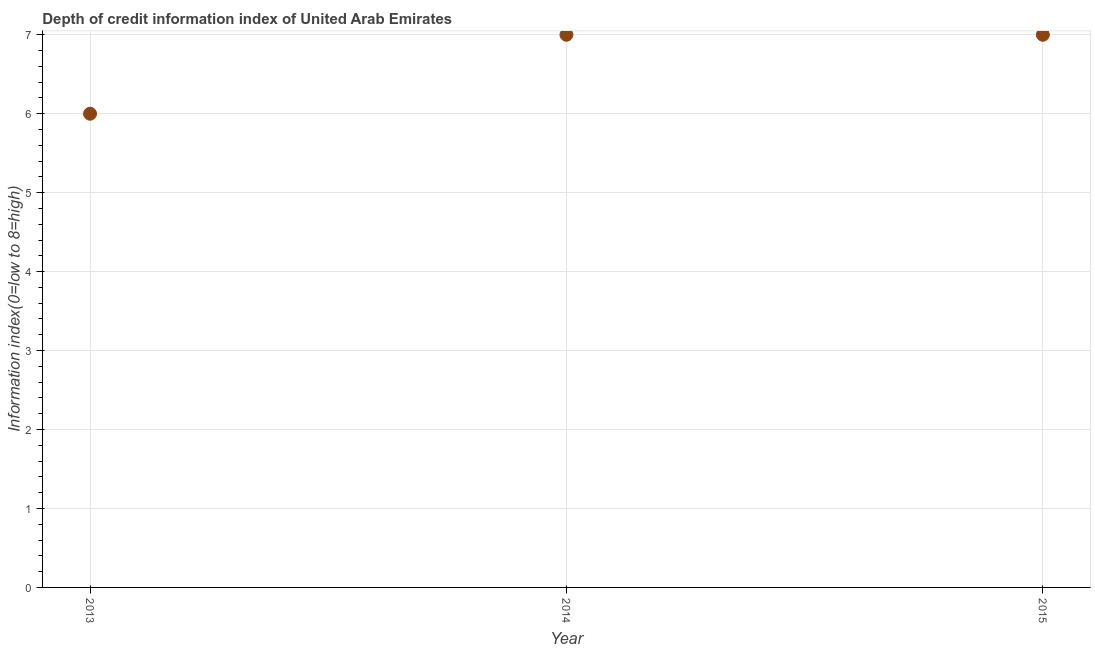What is the depth of credit information index in 2014?
Your response must be concise. 7. Across all years, what is the maximum depth of credit information index?
Give a very brief answer. 7. In which year was the depth of credit information index maximum?
Keep it short and to the point. 2014. What is the sum of the depth of credit information index?
Offer a terse response. 20. What is the difference between the depth of credit information index in 2013 and 2015?
Provide a short and direct response. -1. What is the average depth of credit information index per year?
Keep it short and to the point. 6.67. In how many years, is the depth of credit information index greater than 1.6 ?
Ensure brevity in your answer.  3. What is the ratio of the depth of credit information index in 2013 to that in 2015?
Ensure brevity in your answer.  0.86. What is the difference between the highest and the lowest depth of credit information index?
Offer a very short reply. 1. In how many years, is the depth of credit information index greater than the average depth of credit information index taken over all years?
Your answer should be compact. 2. Does the depth of credit information index monotonically increase over the years?
Ensure brevity in your answer.  No. How many dotlines are there?
Give a very brief answer. 1. What is the difference between two consecutive major ticks on the Y-axis?
Provide a short and direct response. 1. What is the title of the graph?
Your response must be concise. Depth of credit information index of United Arab Emirates. What is the label or title of the Y-axis?
Your answer should be compact. Information index(0=low to 8=high). What is the Information index(0=low to 8=high) in 2015?
Your answer should be very brief. 7. What is the difference between the Information index(0=low to 8=high) in 2013 and 2015?
Your response must be concise. -1. What is the difference between the Information index(0=low to 8=high) in 2014 and 2015?
Give a very brief answer. 0. What is the ratio of the Information index(0=low to 8=high) in 2013 to that in 2014?
Provide a succinct answer. 0.86. What is the ratio of the Information index(0=low to 8=high) in 2013 to that in 2015?
Your response must be concise. 0.86. What is the ratio of the Information index(0=low to 8=high) in 2014 to that in 2015?
Ensure brevity in your answer.  1. 